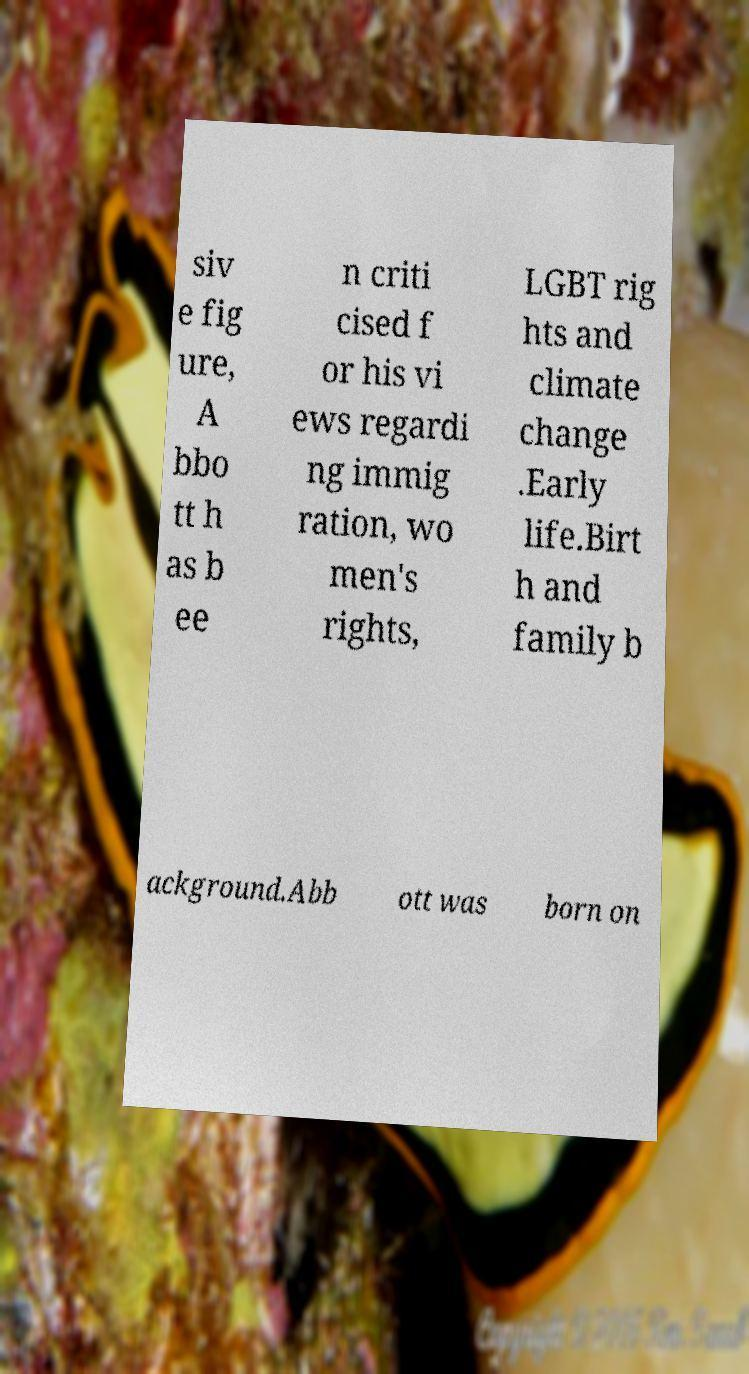Please read and relay the text visible in this image. What does it say? siv e fig ure, A bbo tt h as b ee n criti cised f or his vi ews regardi ng immig ration, wo men's rights, LGBT rig hts and climate change .Early life.Birt h and family b ackground.Abb ott was born on 